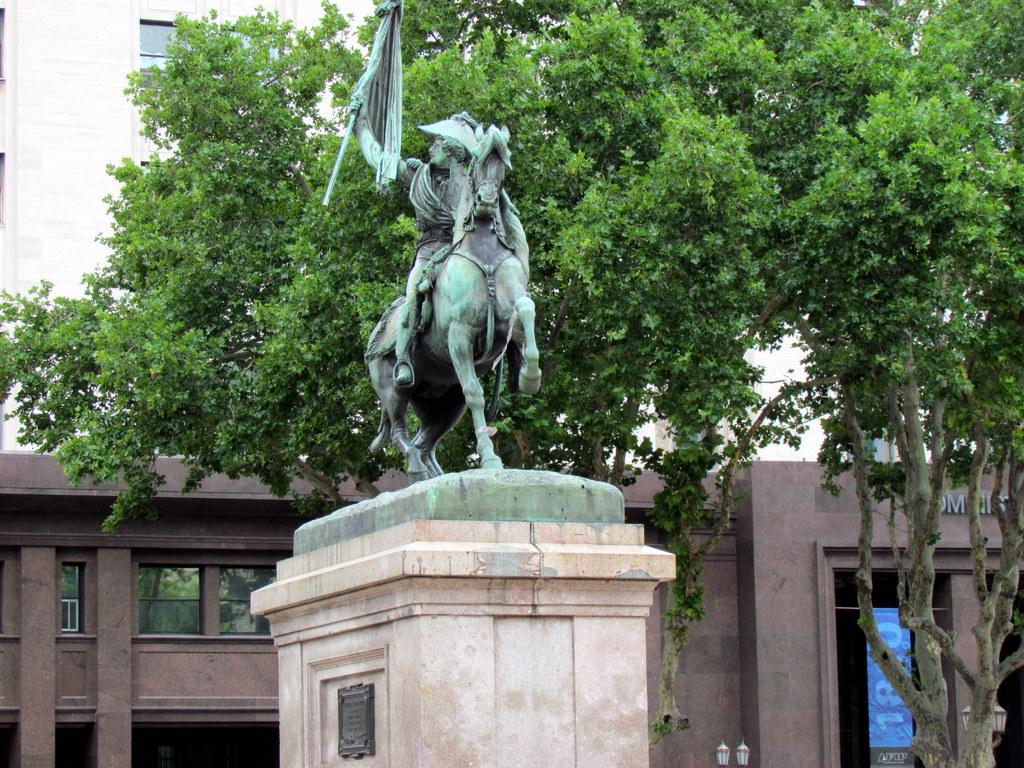What is located in front of the organization in the image? There is a sculpture in front of the organization. What is situated beside the sculpture? There is a huge tree beside the sculpture. What can be seen behind the tree in the image? There is a big building with many windows behind the tree. Can you see any wounds on the tree in the image? There is no mention of any wounds on the tree in the image, and it is not possible to determine the presence of wounds from the provided facts. Is there a mailbox visible in the image? There is no mention of a mailbox in the image, and it is not possible to determine the presence of a mailbox from the provided facts. 